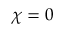Convert formula to latex. <formula><loc_0><loc_0><loc_500><loc_500>\chi = 0</formula> 